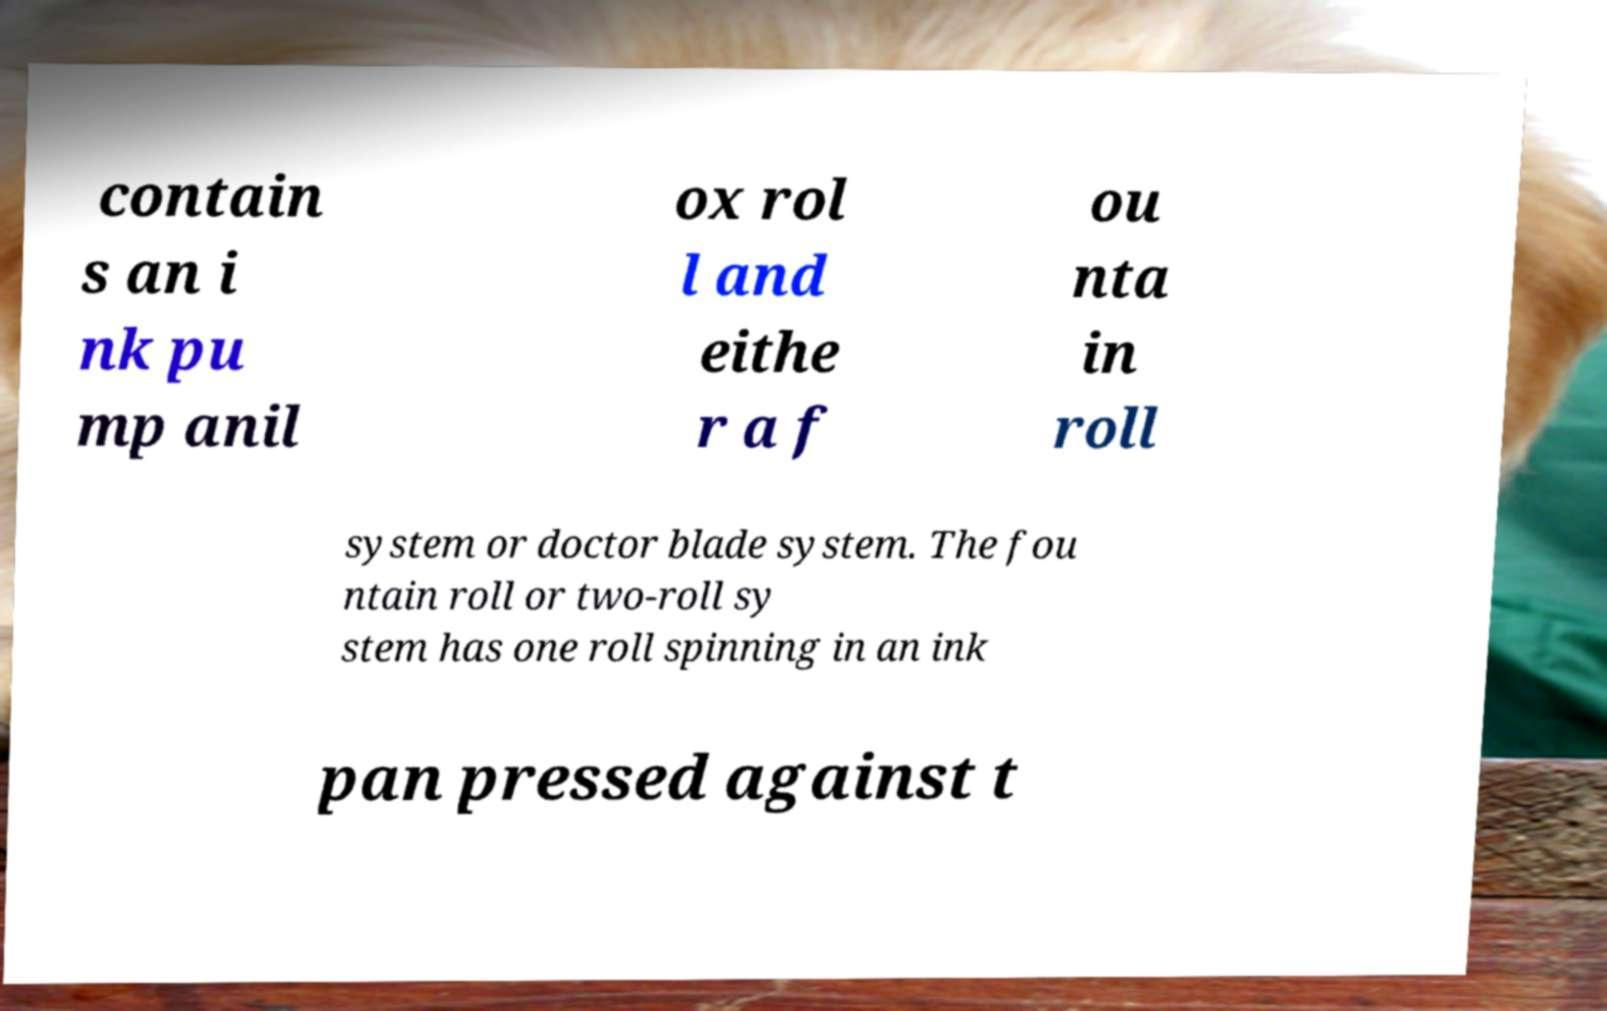Could you assist in decoding the text presented in this image and type it out clearly? contain s an i nk pu mp anil ox rol l and eithe r a f ou nta in roll system or doctor blade system. The fou ntain roll or two-roll sy stem has one roll spinning in an ink pan pressed against t 